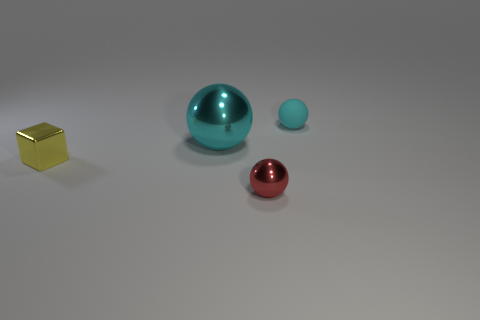There is a metal thing that is on the left side of the cyan object that is left of the shiny ball to the right of the cyan metal sphere; what is its color?
Keep it short and to the point. Yellow. Do the large cyan sphere and the red ball have the same material?
Provide a succinct answer. Yes. How many cyan things are either tiny things or big balls?
Offer a very short reply. 2. There is a tiny cyan rubber sphere; how many small cyan balls are behind it?
Offer a very short reply. 0. Is the number of yellow shiny blocks greater than the number of large rubber things?
Make the answer very short. Yes. What shape is the cyan object in front of the thing to the right of the red metal object?
Keep it short and to the point. Sphere. Is the color of the cube the same as the small matte sphere?
Provide a short and direct response. No. Are there more small red shiny objects that are on the left side of the small red metallic sphere than purple rubber balls?
Your response must be concise. No. There is a cyan sphere behind the large sphere; what number of cyan balls are in front of it?
Keep it short and to the point. 1. Does the tiny ball in front of the large object have the same material as the cyan object behind the big metallic sphere?
Offer a very short reply. No. 